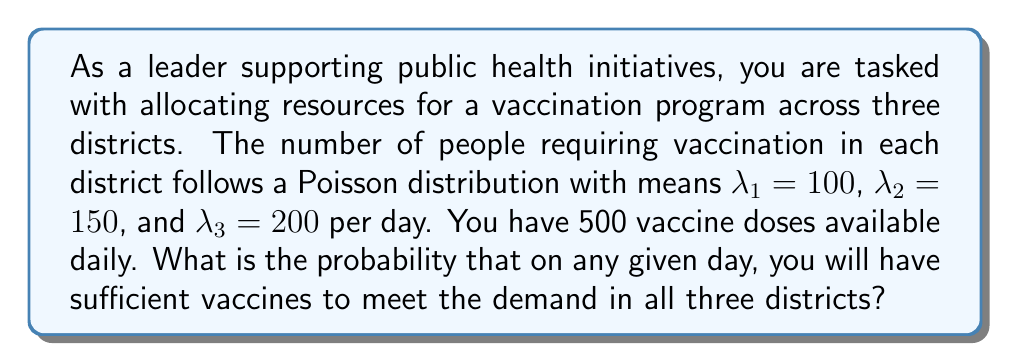Provide a solution to this math problem. Let's approach this step-by-step:

1) Let $X_1$, $X_2$, and $X_3$ be the random variables representing the number of people requiring vaccination in districts 1, 2, and 3 respectively.

2) Given: $X_1 \sim \text{Poisson}(100)$, $X_2 \sim \text{Poisson}(150)$, $X_3 \sim \text{Poisson}(200)$

3) We need to find $P(X_1 + X_2 + X_3 \leq 500)$

4) A key property of Poisson distributions is that the sum of independent Poisson random variables is also Poisson distributed. The parameter of the resulting distribution is the sum of the individual parameters.

5) Therefore, $X_1 + X_2 + X_3 \sim \text{Poisson}(100 + 150 + 200) = \text{Poisson}(450)$

6) Let $Y = X_1 + X_2 + X_3$. We need to calculate $P(Y \leq 500)$

7) For a Poisson distribution with large $\lambda$ (like 450), we can use the normal approximation:

   $Y \approx N(\mu = 450, \sigma^2 = 450)$

8) Standardizing:

   $Z = \frac{Y - 450}{\sqrt{450}}$

9) We need to find:

   $P(Y \leq 500) = P(Z \leq \frac{500 - 450}{\sqrt{450}}) = P(Z \leq \frac{50}{\sqrt{450}}) \approx P(Z \leq 2.36)$

10) Using a standard normal table or calculator, we find:

    $P(Z \leq 2.36) \approx 0.9909$

Therefore, the probability of having sufficient vaccines is approximately 0.9909 or 99.09%.
Answer: $0.9909$ 